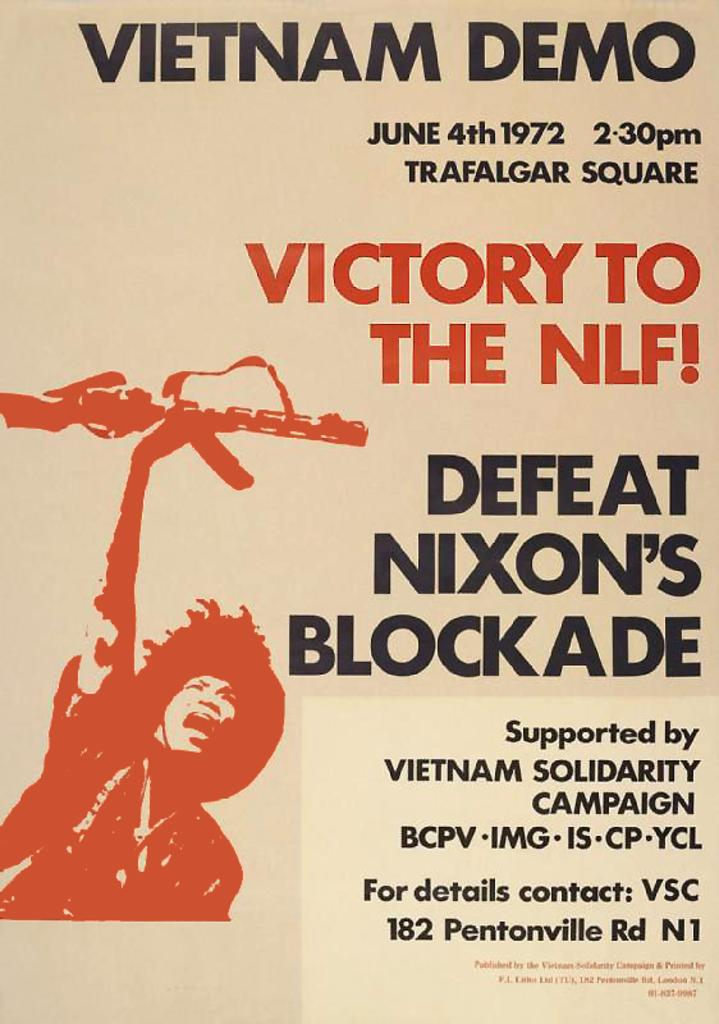<image>
Create a compact narrative representing the image presented. A poster shows an even will take place on June 4th 1972 to defeat Nixon's blockade. 